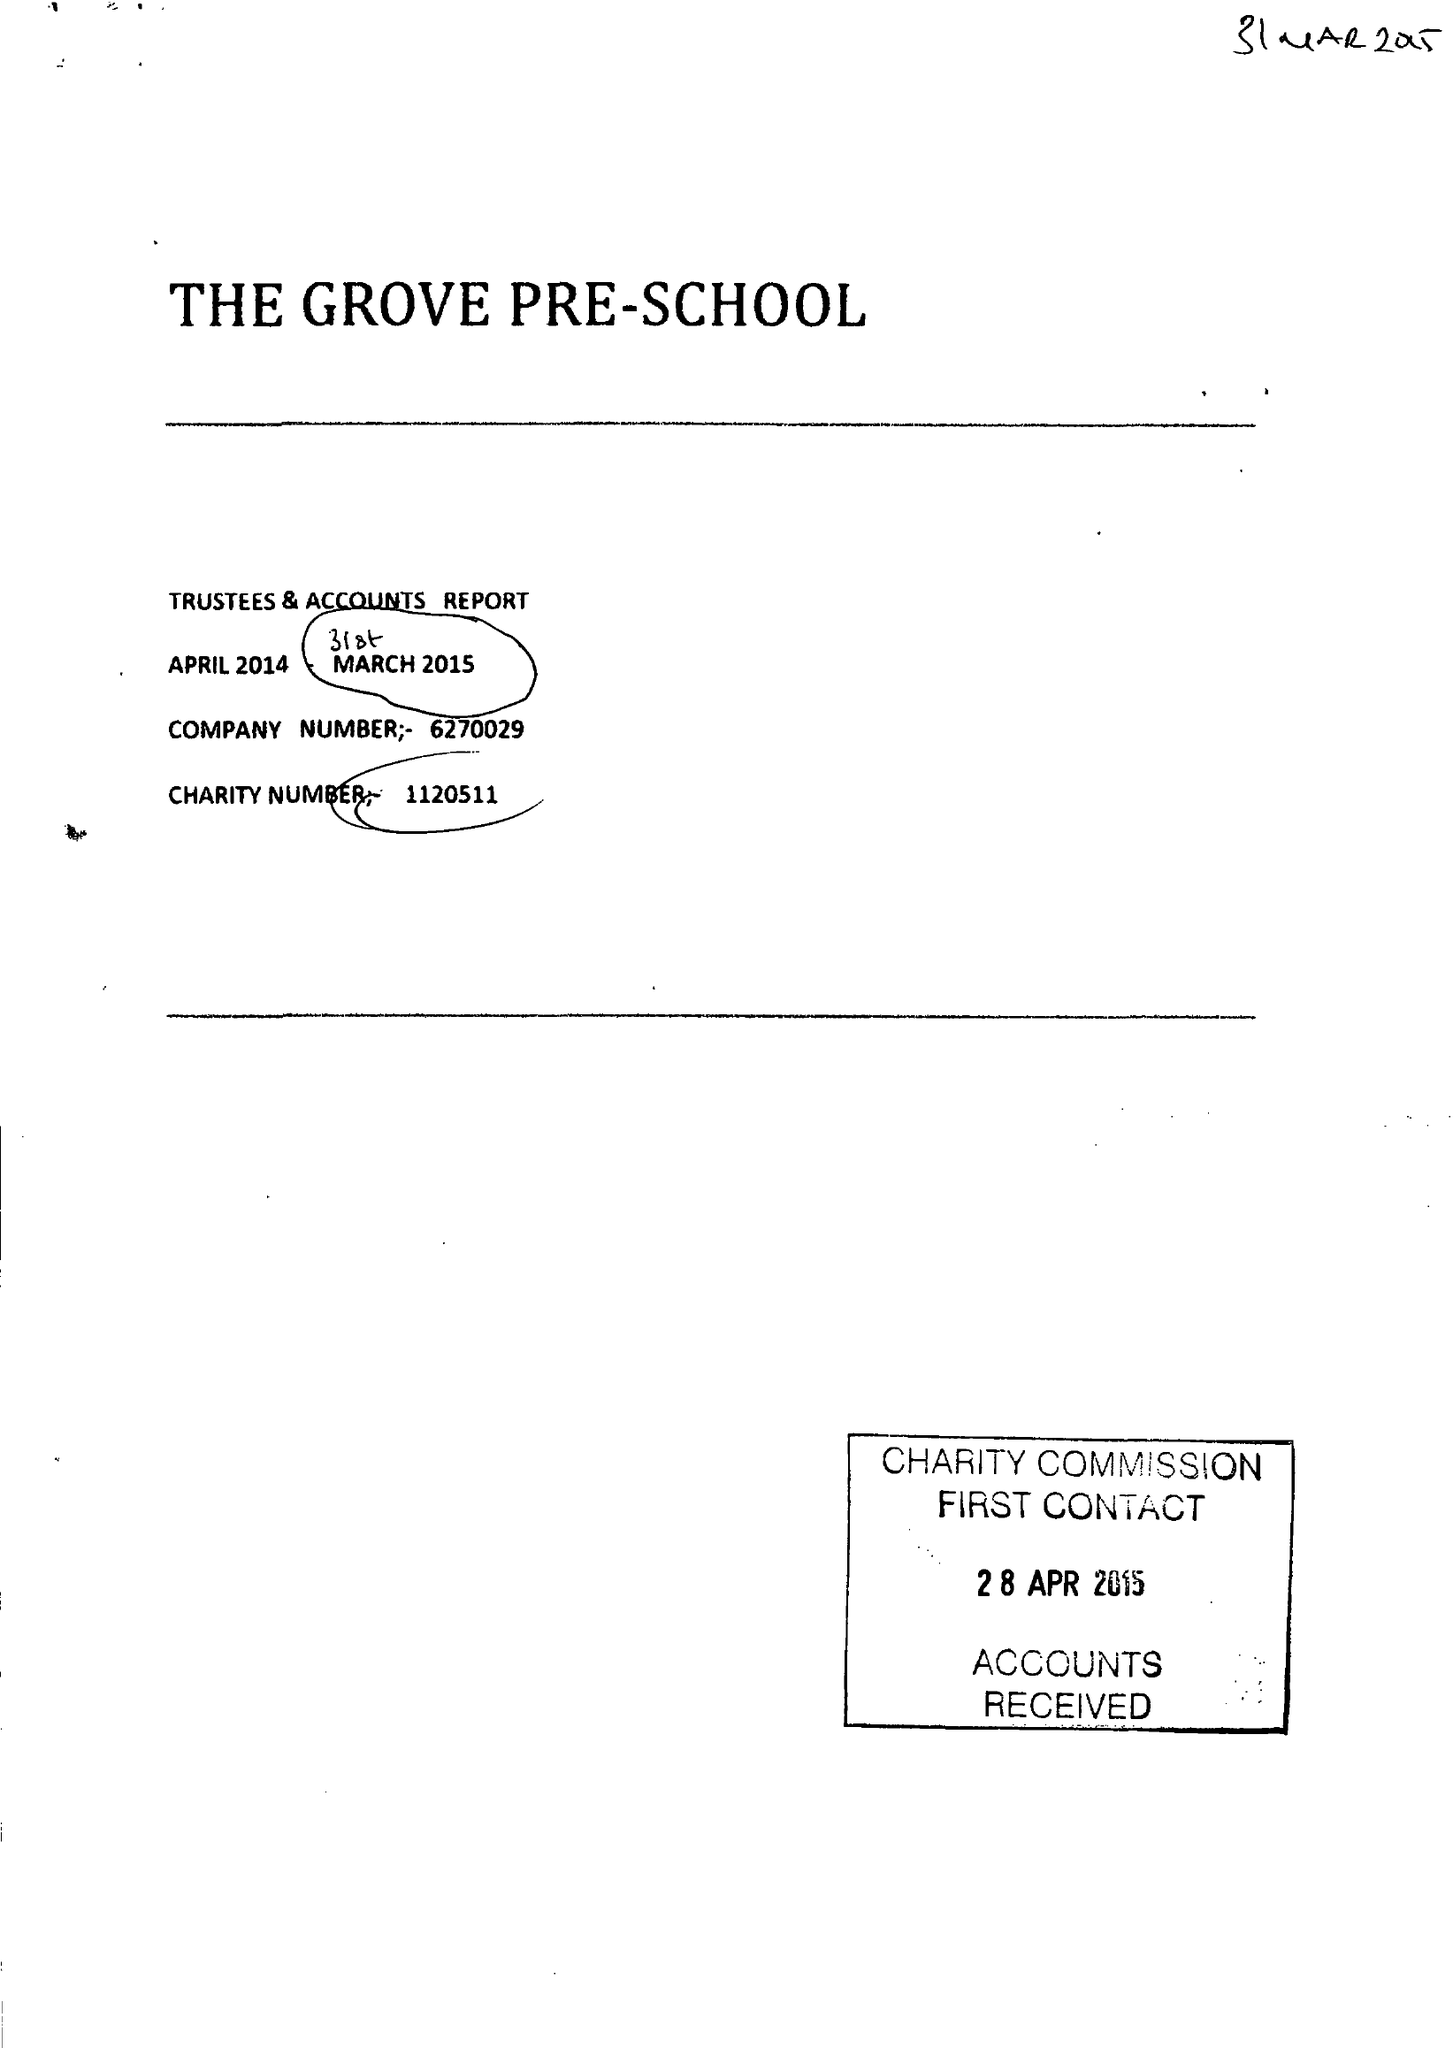What is the value for the report_date?
Answer the question using a single word or phrase. 2015-03-31 